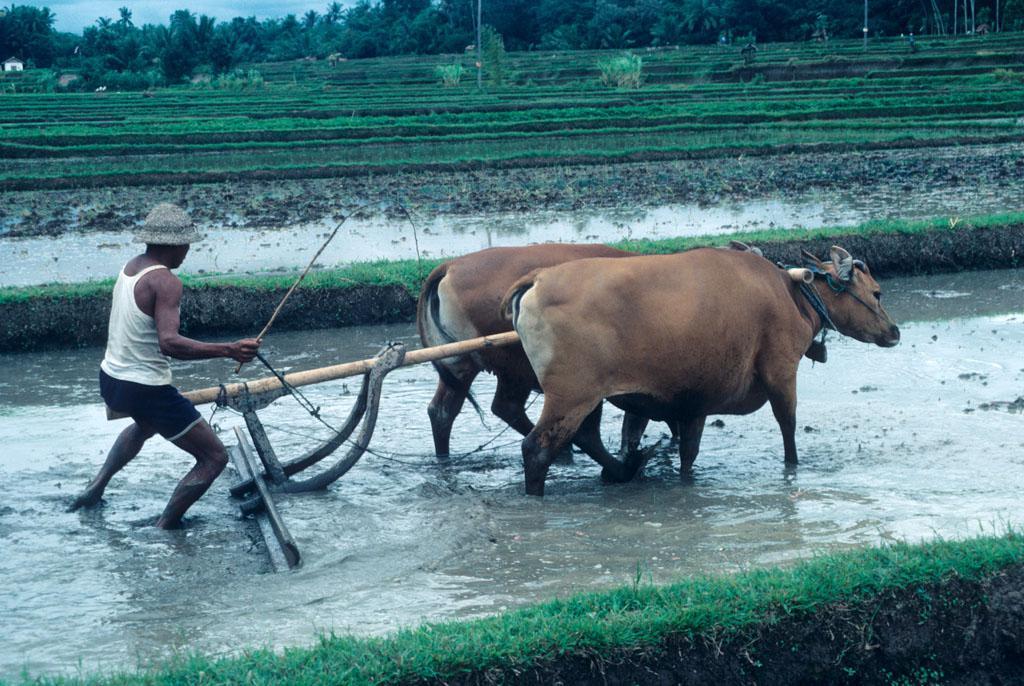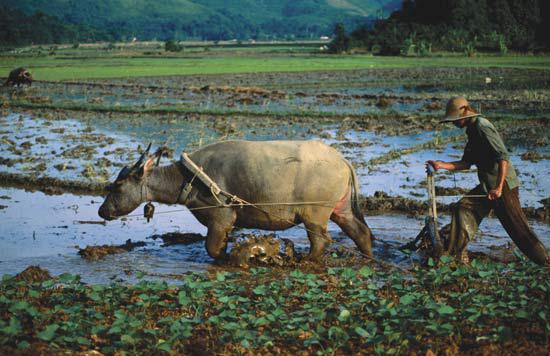The first image is the image on the left, the second image is the image on the right. Analyze the images presented: Is the assertion "Both images show men behind oxen pulling plows." valid? Answer yes or no. Yes. 